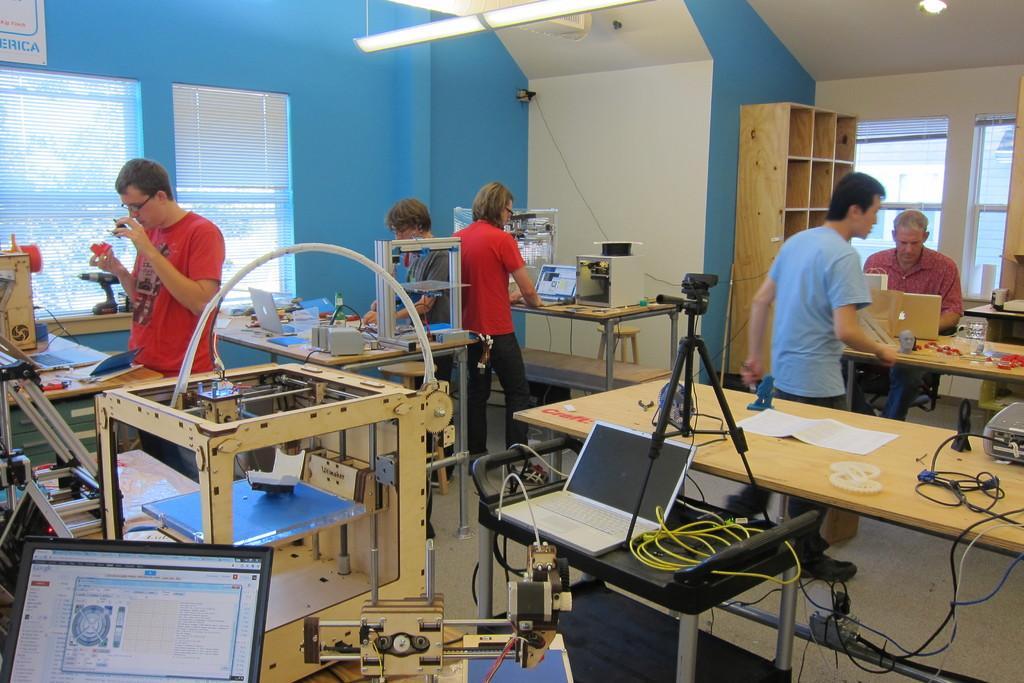Could you give a brief overview of what you see in this image? In this image, we can see a lab contains tables, laptops and equipment. There is a rack in front of the wall. There is a light at the top of the image. There are windows on the left and on the right side of the image. 